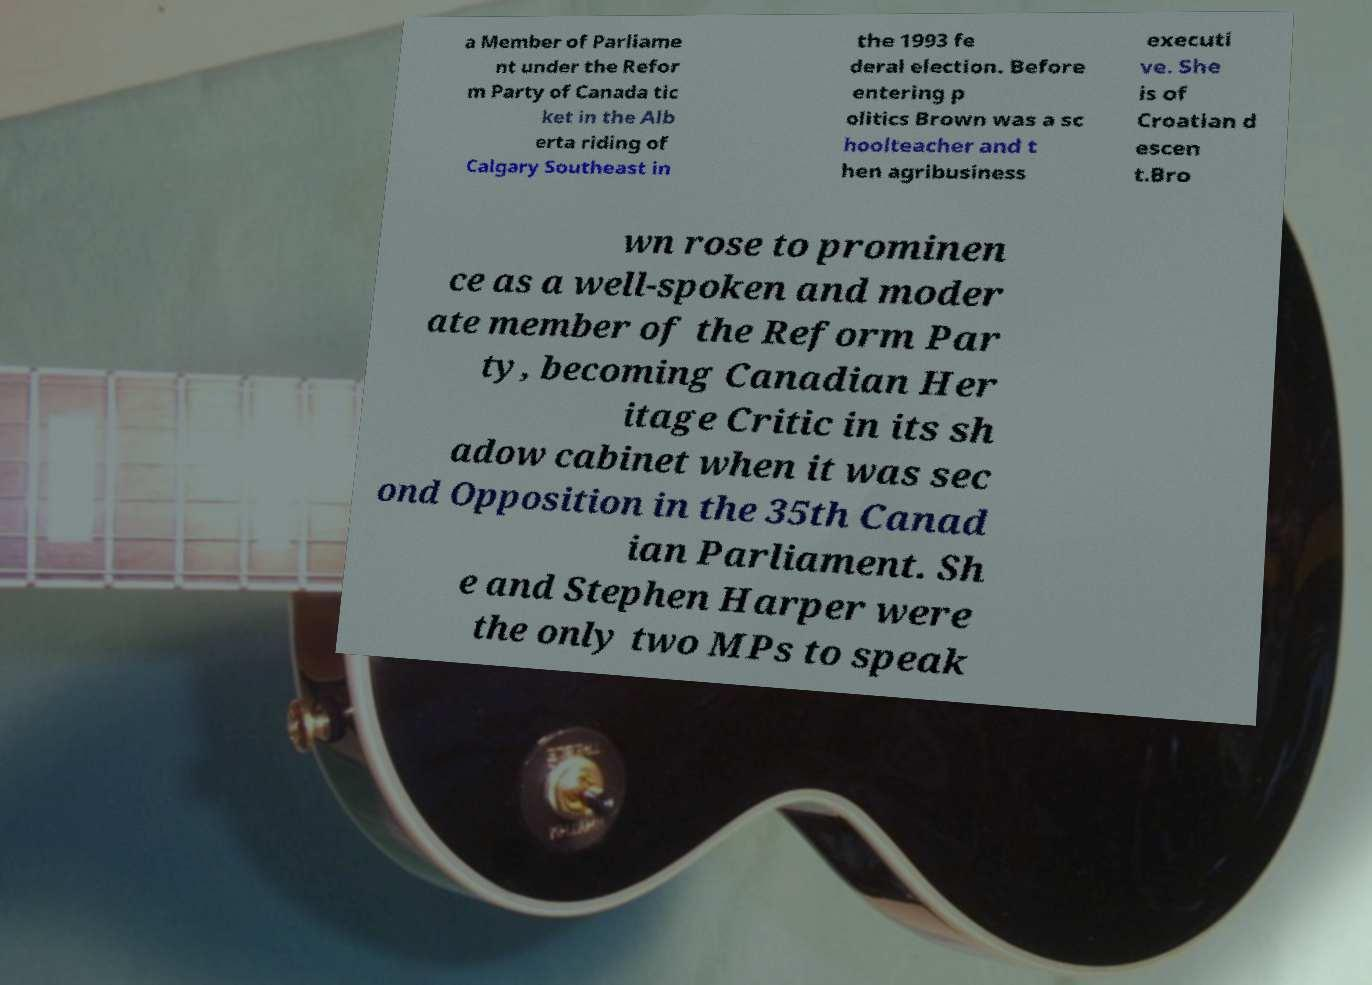Please read and relay the text visible in this image. What does it say? a Member of Parliame nt under the Refor m Party of Canada tic ket in the Alb erta riding of Calgary Southeast in the 1993 fe deral election. Before entering p olitics Brown was a sc hoolteacher and t hen agribusiness executi ve. She is of Croatian d escen t.Bro wn rose to prominen ce as a well-spoken and moder ate member of the Reform Par ty, becoming Canadian Her itage Critic in its sh adow cabinet when it was sec ond Opposition in the 35th Canad ian Parliament. Sh e and Stephen Harper were the only two MPs to speak 